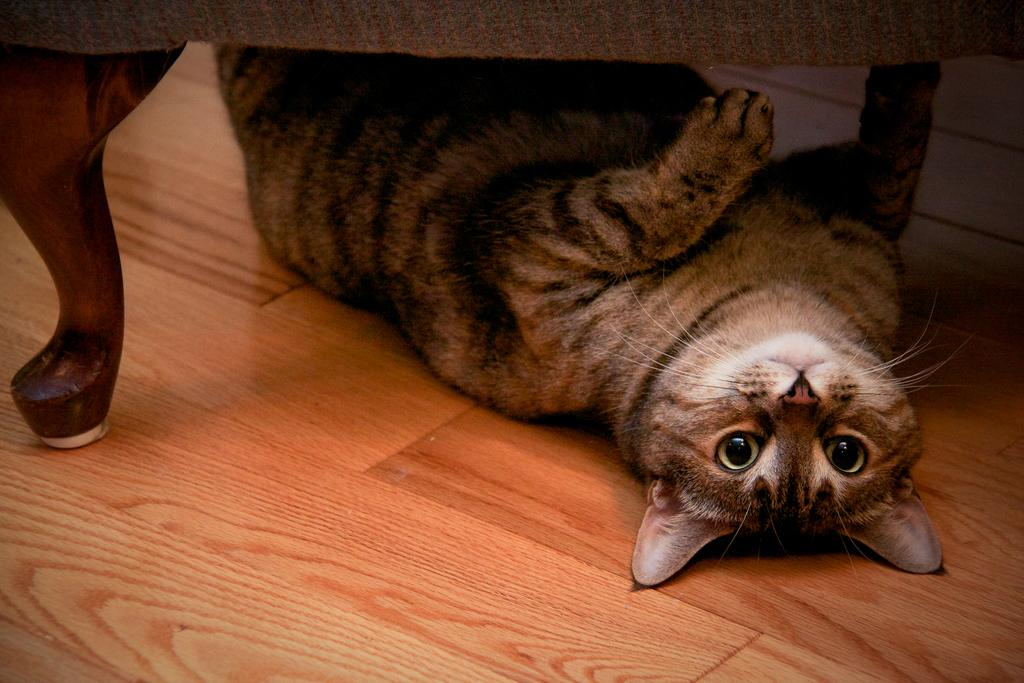What type of animal is in the image? There is a cat in the image. Where is the cat located in the image? The cat is lying under a table. What type of produce is the cat holding in the image? There is no produce present in the image, as it features a cat lying under a table. 